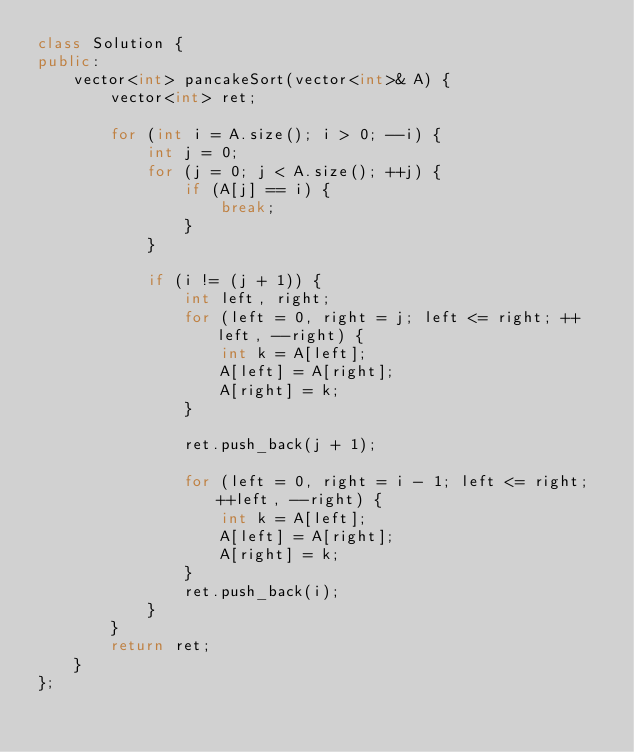<code> <loc_0><loc_0><loc_500><loc_500><_C++_>class Solution {
public:
	vector<int> pancakeSort(vector<int>& A) {
		vector<int> ret;

		for (int i = A.size(); i > 0; --i) {
			int j = 0;
			for (j = 0; j < A.size(); ++j) {
				if (A[j] == i) {
					break;
				}
			}

			if (i != (j + 1)) {
				int left, right;
				for (left = 0, right = j; left <= right; ++left, --right) {
					int k = A[left];
					A[left] = A[right];
					A[right] = k;
				}

				ret.push_back(j + 1);

				for (left = 0, right = i - 1; left <= right; ++left, --right) {
					int k = A[left];
					A[left] = A[right];
					A[right] = k;                    
				}
				ret.push_back(i);
			}
		}
		return ret;
	}
};
</code> 